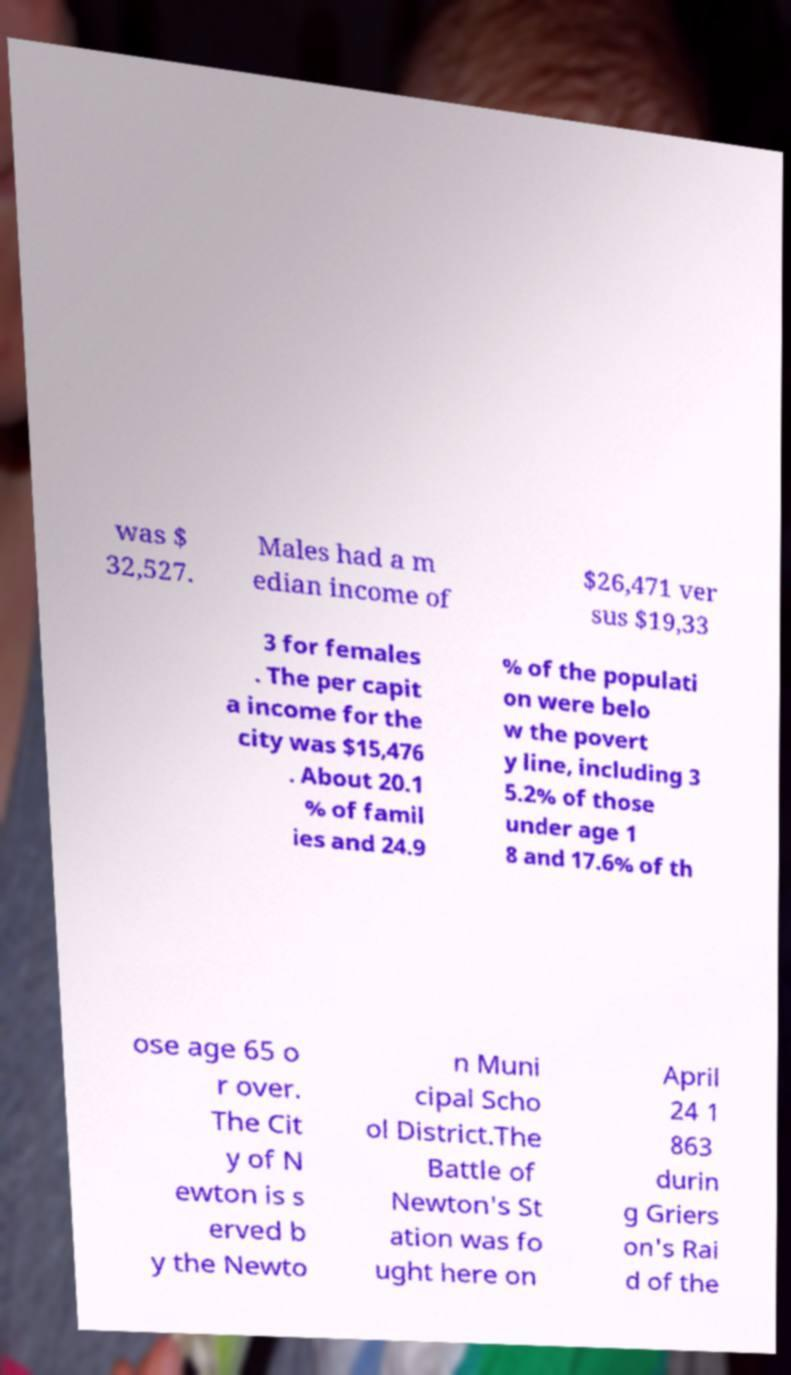Can you accurately transcribe the text from the provided image for me? was $ 32,527. Males had a m edian income of $26,471 ver sus $19,33 3 for females . The per capit a income for the city was $15,476 . About 20.1 % of famil ies and 24.9 % of the populati on were belo w the povert y line, including 3 5.2% of those under age 1 8 and 17.6% of th ose age 65 o r over. The Cit y of N ewton is s erved b y the Newto n Muni cipal Scho ol District.The Battle of Newton's St ation was fo ught here on April 24 1 863 durin g Griers on's Rai d of the 